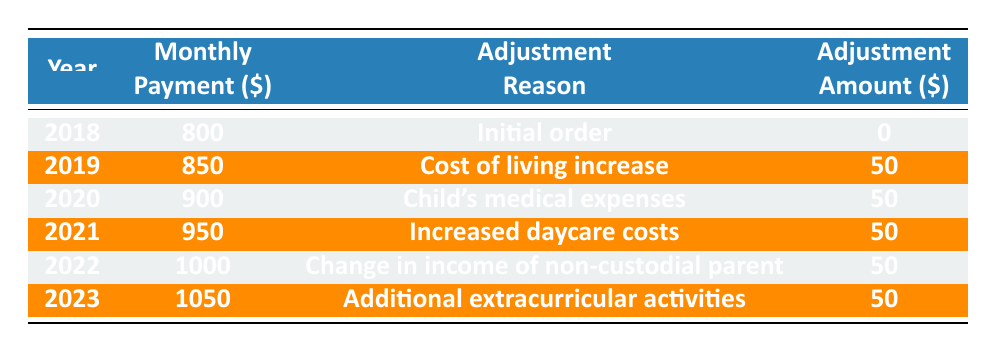What was the monthly child support payment in 2018? The table shows that for the year 2018, the monthly payment was 800.
Answer: 800 What was the reason for the adjustment in 2019? The table lists the adjustment reason for 2019 as "Cost of living increase."
Answer: Cost of living increase How much did the monthly payment increase from 2018 to 2023? In 2018, the monthly payment was 800, and in 2023, it was 1050. The increase is calculated as 1050 - 800 = 250.
Answer: 250 Was there an adjustment amount for the year 2018? For the year 2018, the adjustment amount was 0 as per the table.
Answer: No What is the average monthly payment from 2018 to 2023? To find the average, we sum the monthly payments: 800 + 850 + 900 + 950 + 1000 + 1050 = 4550. There are 6 years, so the average is 4550 / 6 ≈ 758.33.
Answer: 758.33 Which year had the highest monthly payment, and what was it? The table shows that 2023 had the highest monthly payment of 1050.
Answer: 2023, 1050 How many times was the adjustment amount 50 over the years? The adjustment amount was 50 for the years 2019, 2020, 2021, 2022, and 2023. This counts as 5 instances.
Answer: 5 Was there any year where the adjustment reason was related to expenses for the child? Yes, the years 2020 (Child's medical expenses) and 2021 (Increased daycare costs) had adjustment reasons related to child expenses.
Answer: Yes What was the total adjustment amount over all the years listed? The adjustment amounts were: 0 + 50 + 50 + 50 + 50 + 50 = 250. The total adjustment amount is 250.
Answer: 250 How did the reasons for adjustments change from 2018 to 2023? In 2018 there was no adjustment, then reasons shifted from cost of living increases to specific expenses such as medical, daycare, income changes, and extracurricular activities from 2019 to 2023.
Answer: They became more specific 